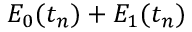<formula> <loc_0><loc_0><loc_500><loc_500>E _ { 0 } ( t _ { n } ) + E _ { 1 } ( t _ { n } )</formula> 